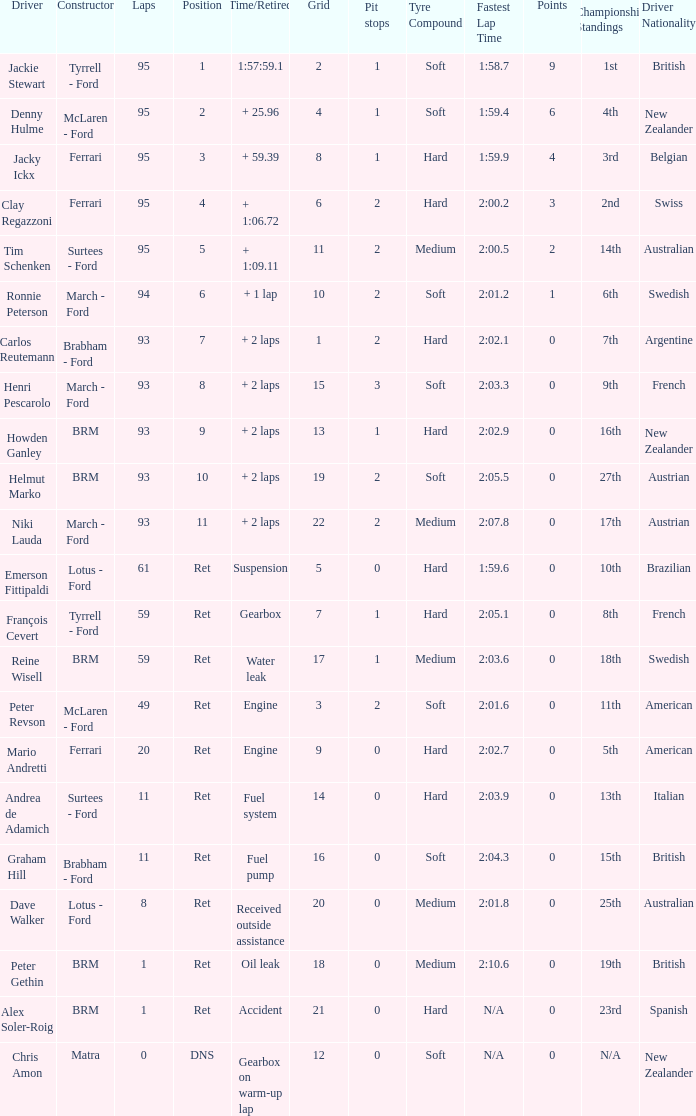What is the least size of a grid with matra as the creator? 12.0. 